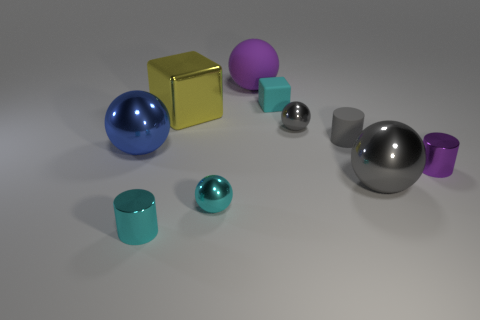There is a large gray ball; are there any metallic things behind it?
Your answer should be compact. Yes. What size is the block that is the same material as the purple cylinder?
Your response must be concise. Large. How many small metal cylinders have the same color as the matte ball?
Make the answer very short. 1. Is the number of large spheres in front of the big blue ball less than the number of purple cylinders that are behind the large yellow object?
Provide a succinct answer. No. How big is the gray ball right of the small gray metallic ball?
Offer a terse response. Large. The cylinder that is the same color as the rubber ball is what size?
Provide a succinct answer. Small. Are there any large cyan blocks made of the same material as the big yellow object?
Offer a very short reply. No. Does the gray cylinder have the same material as the small cube?
Offer a very short reply. Yes. What is the color of the rubber cube that is the same size as the gray cylinder?
Your answer should be compact. Cyan. What number of other objects are the same shape as the blue object?
Your answer should be very brief. 4. 